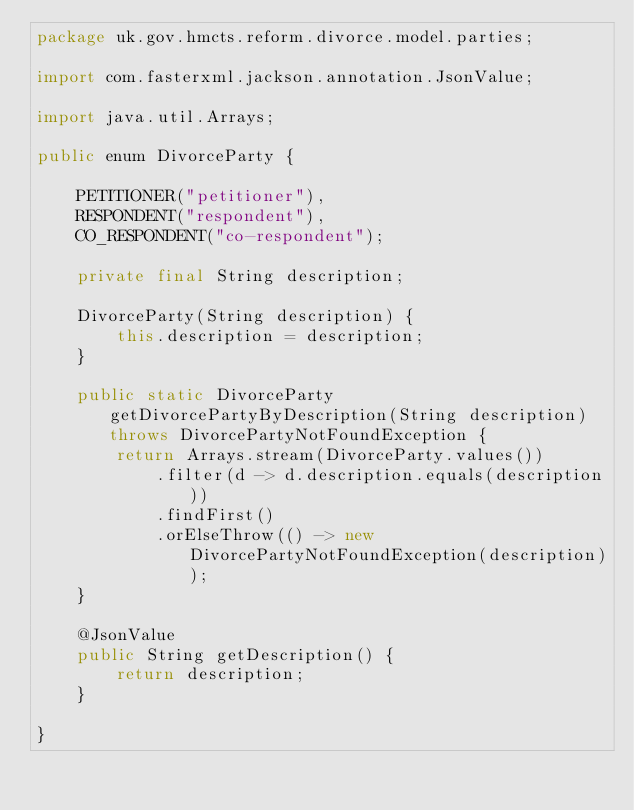Convert code to text. <code><loc_0><loc_0><loc_500><loc_500><_Java_>package uk.gov.hmcts.reform.divorce.model.parties;

import com.fasterxml.jackson.annotation.JsonValue;

import java.util.Arrays;

public enum DivorceParty {

    PETITIONER("petitioner"),
    RESPONDENT("respondent"),
    CO_RESPONDENT("co-respondent");

    private final String description;

    DivorceParty(String description) {
        this.description = description;
    }

    public static DivorceParty getDivorcePartyByDescription(String description) throws DivorcePartyNotFoundException {
        return Arrays.stream(DivorceParty.values())
            .filter(d -> d.description.equals(description))
            .findFirst()
            .orElseThrow(() -> new DivorcePartyNotFoundException(description));
    }

    @JsonValue
    public String getDescription() {
        return description;
    }

}</code> 